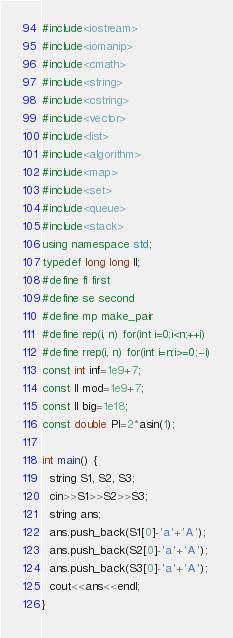Convert code to text. <code><loc_0><loc_0><loc_500><loc_500><_C++_>#include<iostream>
#include<iomanip>
#include<cmath>
#include<string>
#include<cstring>
#include<vector>
#include<list>
#include<algorithm>
#include<map>
#include<set>
#include<queue>
#include<stack>
using namespace std;
typedef long long ll;
#define fi first
#define se second
#define mp make_pair
#define rep(i, n) for(int i=0;i<n;++i)
#define rrep(i, n) for(int i=n;i>=0;--i)
const int inf=1e9+7;
const ll mod=1e9+7;
const ll big=1e18;
const double PI=2*asin(1);

int main() {
  string S1, S2, S3;
  cin>>S1>>S2>>S3;
  string ans;
  ans.push_back(S1[0]-'a'+'A');
  ans.push_back(S2[0]-'a'+'A');
  ans.push_back(S3[0]-'a'+'A');
  cout<<ans<<endl;
}

</code> 